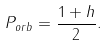<formula> <loc_0><loc_0><loc_500><loc_500>P _ { o r b } = \frac { 1 + h } 2 .</formula> 